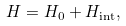<formula> <loc_0><loc_0><loc_500><loc_500>H = H _ { 0 } + H _ { \text {int} } ,</formula> 